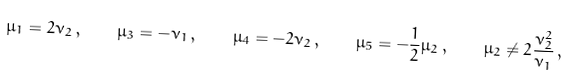Convert formula to latex. <formula><loc_0><loc_0><loc_500><loc_500>\mu _ { 1 } = 2 \nu _ { 2 } \, , \quad \mu _ { 3 } = - \nu _ { 1 } \, , \quad \mu _ { 4 } = - 2 \nu _ { 2 } \, , \quad \mu _ { 5 } = - \frac { 1 } { 2 } \mu _ { 2 } \, , \quad \mu _ { 2 } \neq 2 \frac { \nu _ { 2 } ^ { 2 } } { \nu _ { 1 } } \, ,</formula> 